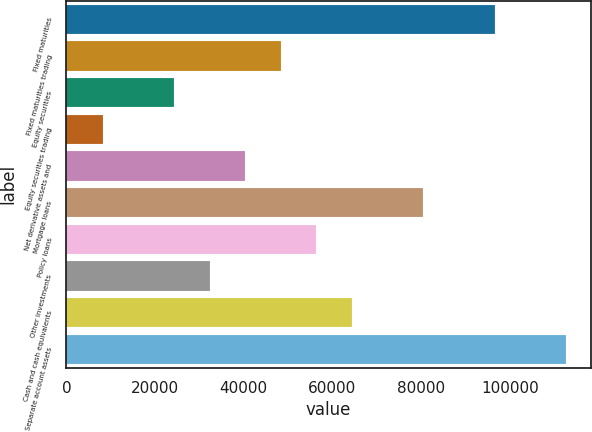<chart> <loc_0><loc_0><loc_500><loc_500><bar_chart><fcel>Fixed maturities<fcel>Fixed maturities trading<fcel>Equity securities<fcel>Equity securities trading<fcel>Net derivative assets and<fcel>Mortgage loans<fcel>Policy loans<fcel>Other investments<fcel>Cash and cash equivalents<fcel>Separate account assets<nl><fcel>96550.9<fcel>48358.6<fcel>24262.4<fcel>8198.26<fcel>40326.5<fcel>80486.8<fcel>56390.6<fcel>32294.4<fcel>64422.7<fcel>112615<nl></chart> 